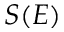<formula> <loc_0><loc_0><loc_500><loc_500>S ( E )</formula> 